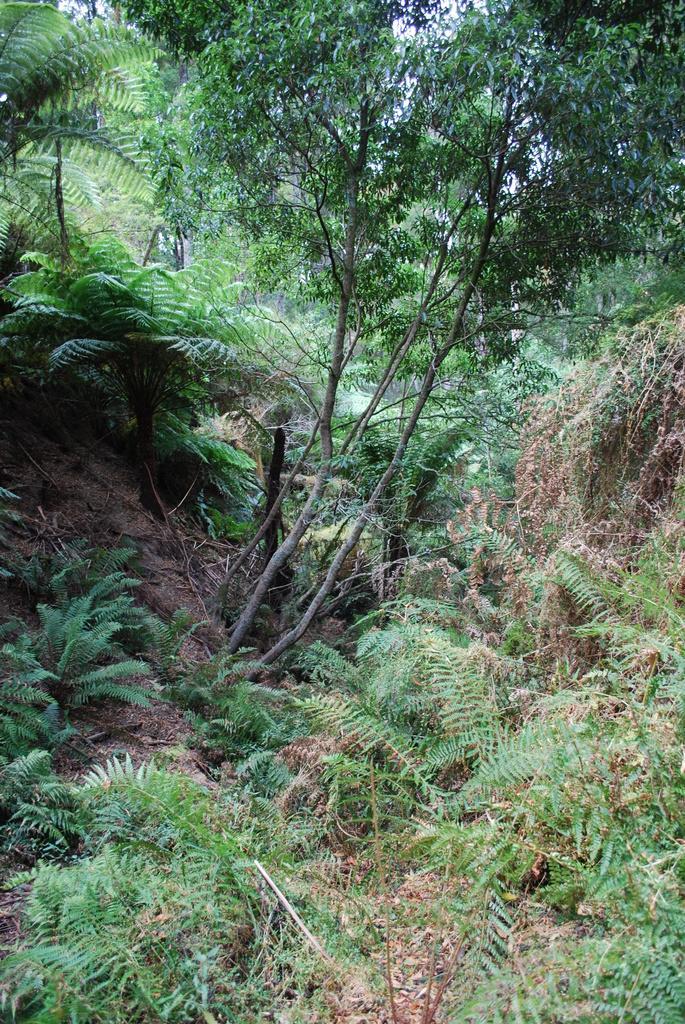In one or two sentences, can you explain what this image depicts? In this picture we can see trees and plants. In the background of the image we can see the sky. 